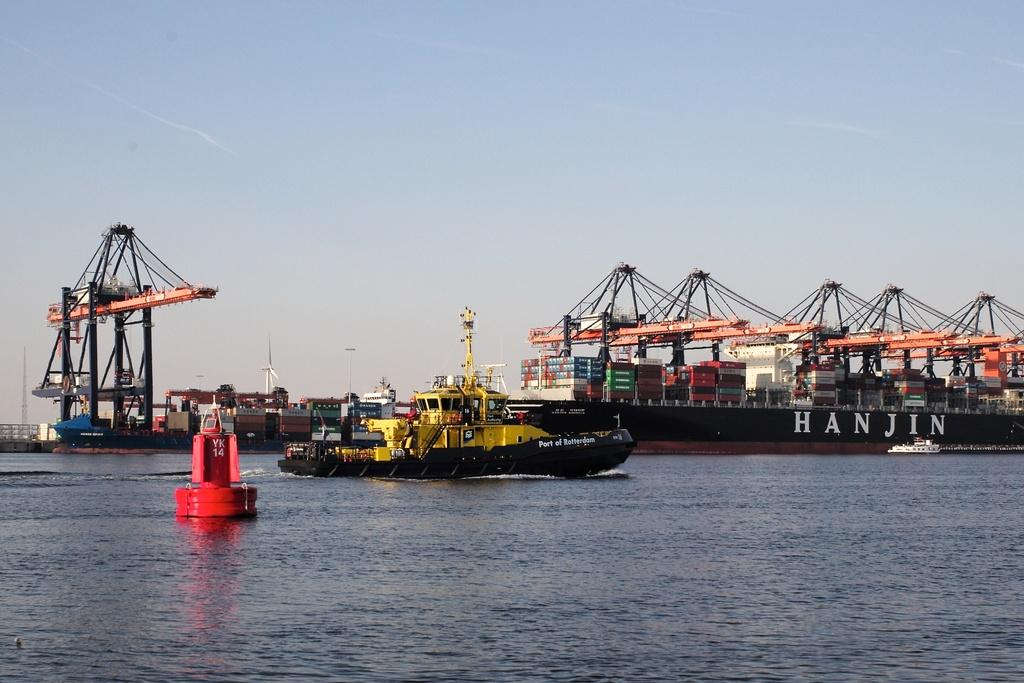What is in the water in the image? There are ships in the water. What can be seen in the background of the image? There are windmills, towers, buildings, and the sky visible in the background. Can you describe the windmills in the image? The windmills are large structures with blades that rotate in the wind. What type of structures are the towers in the image? The towers are tall, vertical structures that may be used for various purposes, such as observation or communication. How many hens are sitting on the beds in the image? There are no hens or beds present in the image. 